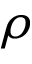Convert formula to latex. <formula><loc_0><loc_0><loc_500><loc_500>\rho</formula> 